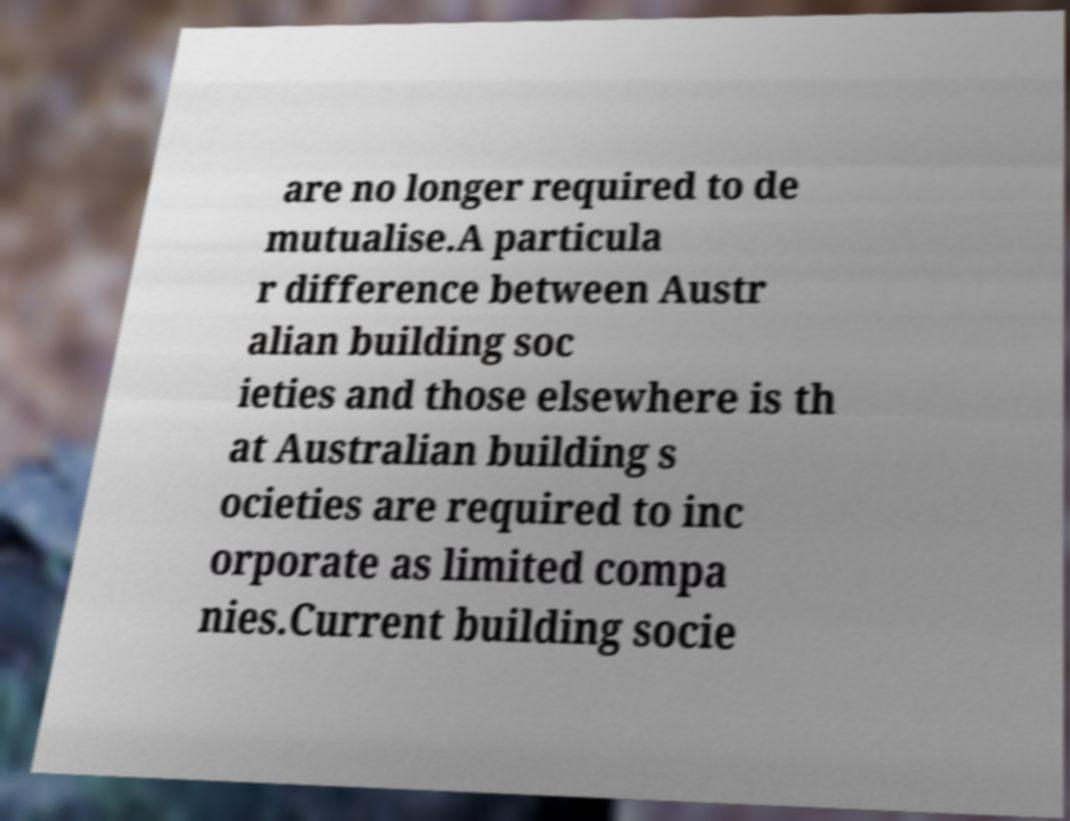Can you accurately transcribe the text from the provided image for me? are no longer required to de mutualise.A particula r difference between Austr alian building soc ieties and those elsewhere is th at Australian building s ocieties are required to inc orporate as limited compa nies.Current building socie 